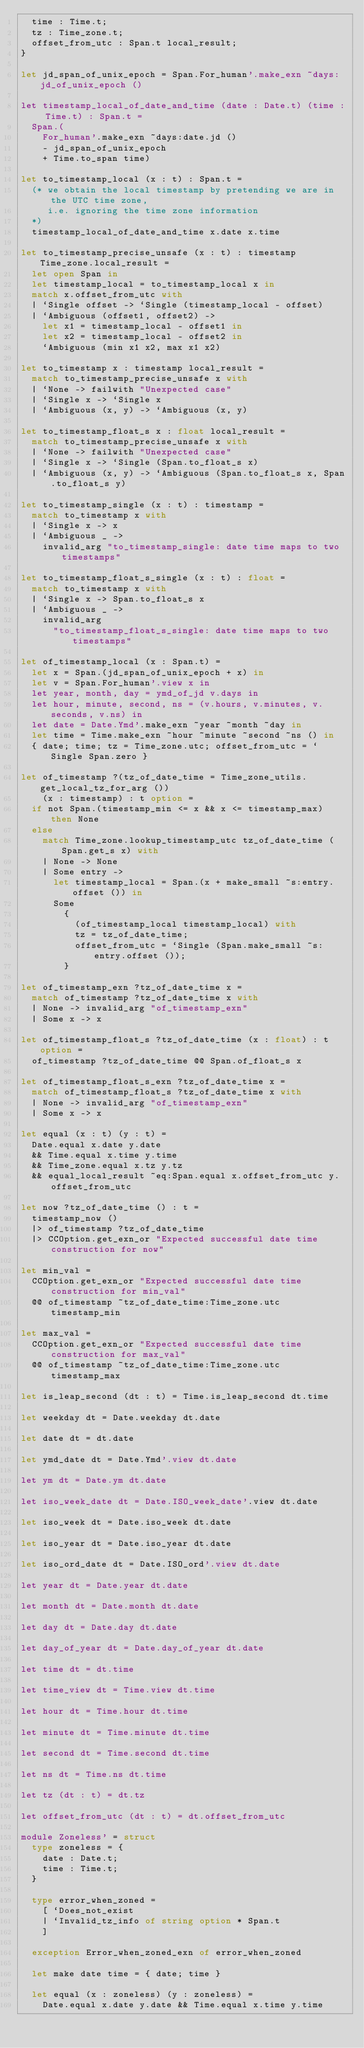<code> <loc_0><loc_0><loc_500><loc_500><_OCaml_>  time : Time.t;
  tz : Time_zone.t;
  offset_from_utc : Span.t local_result;
}

let jd_span_of_unix_epoch = Span.For_human'.make_exn ~days:jd_of_unix_epoch ()

let timestamp_local_of_date_and_time (date : Date.t) (time : Time.t) : Span.t =
  Span.(
    For_human'.make_exn ~days:date.jd ()
    - jd_span_of_unix_epoch
    + Time.to_span time)

let to_timestamp_local (x : t) : Span.t =
  (* we obtain the local timestamp by pretending we are in the UTC time zone,
     i.e. ignoring the time zone information
  *)
  timestamp_local_of_date_and_time x.date x.time

let to_timestamp_precise_unsafe (x : t) : timestamp Time_zone.local_result =
  let open Span in
  let timestamp_local = to_timestamp_local x in
  match x.offset_from_utc with
  | `Single offset -> `Single (timestamp_local - offset)
  | `Ambiguous (offset1, offset2) ->
    let x1 = timestamp_local - offset1 in
    let x2 = timestamp_local - offset2 in
    `Ambiguous (min x1 x2, max x1 x2)

let to_timestamp x : timestamp local_result =
  match to_timestamp_precise_unsafe x with
  | `None -> failwith "Unexpected case"
  | `Single x -> `Single x
  | `Ambiguous (x, y) -> `Ambiguous (x, y)

let to_timestamp_float_s x : float local_result =
  match to_timestamp_precise_unsafe x with
  | `None -> failwith "Unexpected case"
  | `Single x -> `Single (Span.to_float_s x)
  | `Ambiguous (x, y) -> `Ambiguous (Span.to_float_s x, Span.to_float_s y)

let to_timestamp_single (x : t) : timestamp =
  match to_timestamp x with
  | `Single x -> x
  | `Ambiguous _ ->
    invalid_arg "to_timestamp_single: date time maps to two timestamps"

let to_timestamp_float_s_single (x : t) : float =
  match to_timestamp x with
  | `Single x -> Span.to_float_s x
  | `Ambiguous _ ->
    invalid_arg
      "to_timestamp_float_s_single: date time maps to two timestamps"

let of_timestamp_local (x : Span.t) =
  let x = Span.(jd_span_of_unix_epoch + x) in
  let v = Span.For_human'.view x in
  let year, month, day = ymd_of_jd v.days in
  let hour, minute, second, ns = (v.hours, v.minutes, v.seconds, v.ns) in
  let date = Date.Ymd'.make_exn ~year ~month ~day in
  let time = Time.make_exn ~hour ~minute ~second ~ns () in
  { date; time; tz = Time_zone.utc; offset_from_utc = `Single Span.zero }

let of_timestamp ?(tz_of_date_time = Time_zone_utils.get_local_tz_for_arg ())
    (x : timestamp) : t option =
  if not Span.(timestamp_min <= x && x <= timestamp_max) then None
  else
    match Time_zone.lookup_timestamp_utc tz_of_date_time (Span.get_s x) with
    | None -> None
    | Some entry ->
      let timestamp_local = Span.(x + make_small ~s:entry.offset ()) in
      Some
        {
          (of_timestamp_local timestamp_local) with
          tz = tz_of_date_time;
          offset_from_utc = `Single (Span.make_small ~s:entry.offset ());
        }

let of_timestamp_exn ?tz_of_date_time x =
  match of_timestamp ?tz_of_date_time x with
  | None -> invalid_arg "of_timestamp_exn"
  | Some x -> x

let of_timestamp_float_s ?tz_of_date_time (x : float) : t option =
  of_timestamp ?tz_of_date_time @@ Span.of_float_s x

let of_timestamp_float_s_exn ?tz_of_date_time x =
  match of_timestamp_float_s ?tz_of_date_time x with
  | None -> invalid_arg "of_timestamp_exn"
  | Some x -> x

let equal (x : t) (y : t) =
  Date.equal x.date y.date
  && Time.equal x.time y.time
  && Time_zone.equal x.tz y.tz
  && equal_local_result ~eq:Span.equal x.offset_from_utc y.offset_from_utc

let now ?tz_of_date_time () : t =
  timestamp_now ()
  |> of_timestamp ?tz_of_date_time
  |> CCOption.get_exn_or "Expected successful date time construction for now"

let min_val =
  CCOption.get_exn_or "Expected successful date time construction for min_val"
  @@ of_timestamp ~tz_of_date_time:Time_zone.utc timestamp_min

let max_val =
  CCOption.get_exn_or "Expected successful date time construction for max_val"
  @@ of_timestamp ~tz_of_date_time:Time_zone.utc timestamp_max

let is_leap_second (dt : t) = Time.is_leap_second dt.time

let weekday dt = Date.weekday dt.date

let date dt = dt.date

let ymd_date dt = Date.Ymd'.view dt.date

let ym dt = Date.ym dt.date

let iso_week_date dt = Date.ISO_week_date'.view dt.date

let iso_week dt = Date.iso_week dt.date

let iso_year dt = Date.iso_year dt.date

let iso_ord_date dt = Date.ISO_ord'.view dt.date

let year dt = Date.year dt.date

let month dt = Date.month dt.date

let day dt = Date.day dt.date

let day_of_year dt = Date.day_of_year dt.date

let time dt = dt.time

let time_view dt = Time.view dt.time

let hour dt = Time.hour dt.time

let minute dt = Time.minute dt.time

let second dt = Time.second dt.time

let ns dt = Time.ns dt.time

let tz (dt : t) = dt.tz

let offset_from_utc (dt : t) = dt.offset_from_utc

module Zoneless' = struct
  type zoneless = {
    date : Date.t;
    time : Time.t;
  }

  type error_when_zoned =
    [ `Does_not_exist
    | `Invalid_tz_info of string option * Span.t
    ]

  exception Error_when_zoned_exn of error_when_zoned

  let make date time = { date; time }

  let equal (x : zoneless) (y : zoneless) =
    Date.equal x.date y.date && Time.equal x.time y.time
</code> 